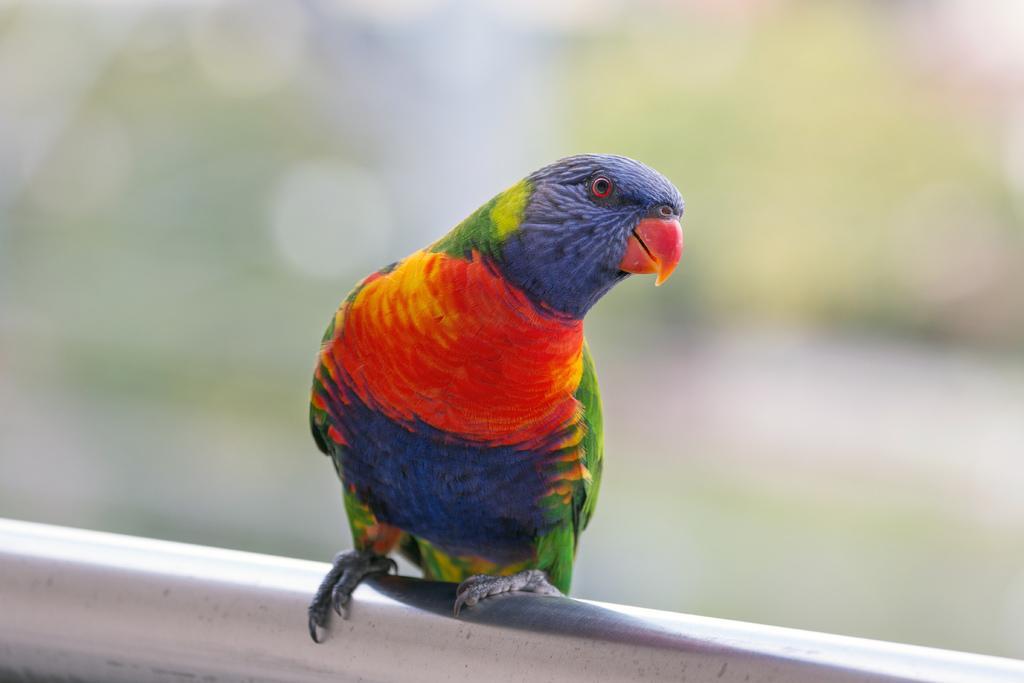Describe this image in one or two sentences. As we can see in the image in the front there is a bird and the background is blurred. 